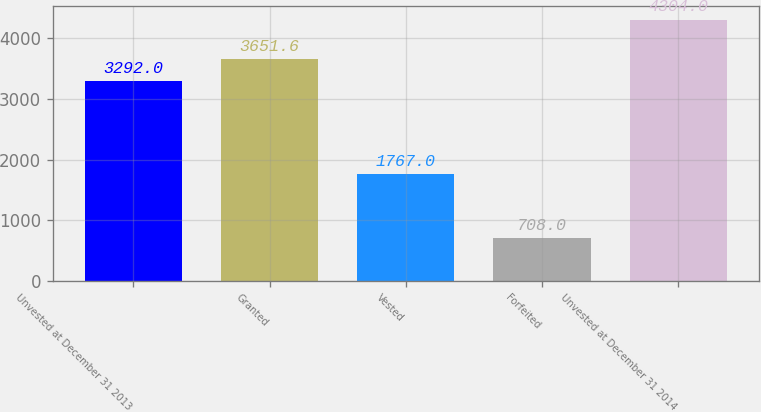Convert chart. <chart><loc_0><loc_0><loc_500><loc_500><bar_chart><fcel>Unvested at December 31 2013<fcel>Granted<fcel>Vested<fcel>Forfeited<fcel>Unvested at December 31 2014<nl><fcel>3292<fcel>3651.6<fcel>1767<fcel>708<fcel>4304<nl></chart> 